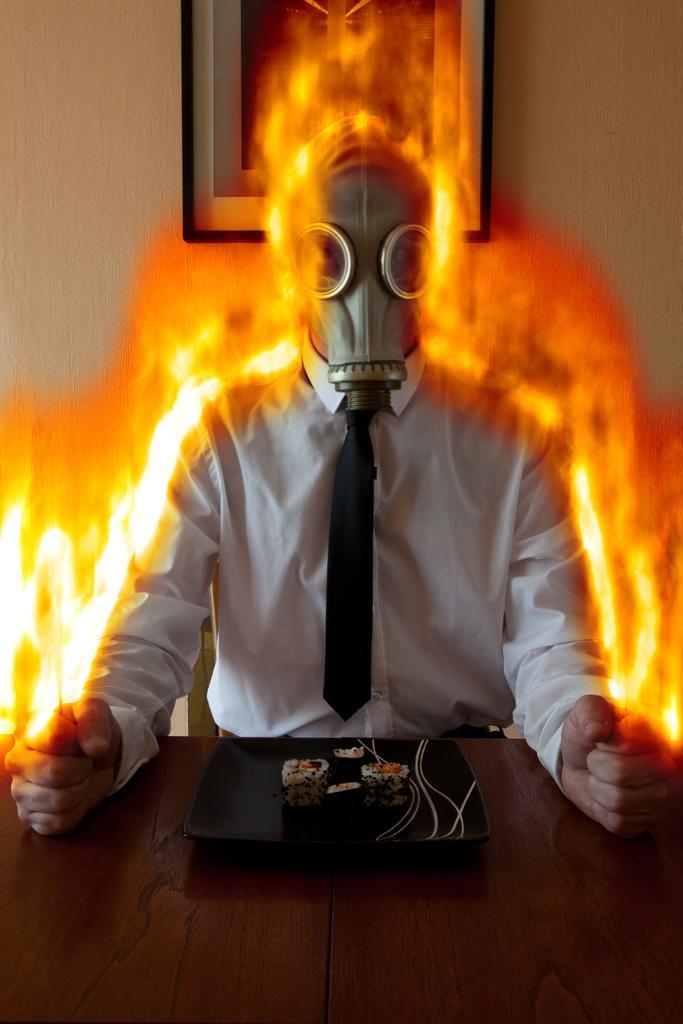How would you summarize this image in a sentence or two? In the picture I can see a person sitting on a chair and there is a mask on his face. I can see the flame. There is a photo frame on the wall at the top of the picture. I can see the wooden table at the bottom of the picture. There is a plate on the table and I can see two pieces of cake on the plate. 